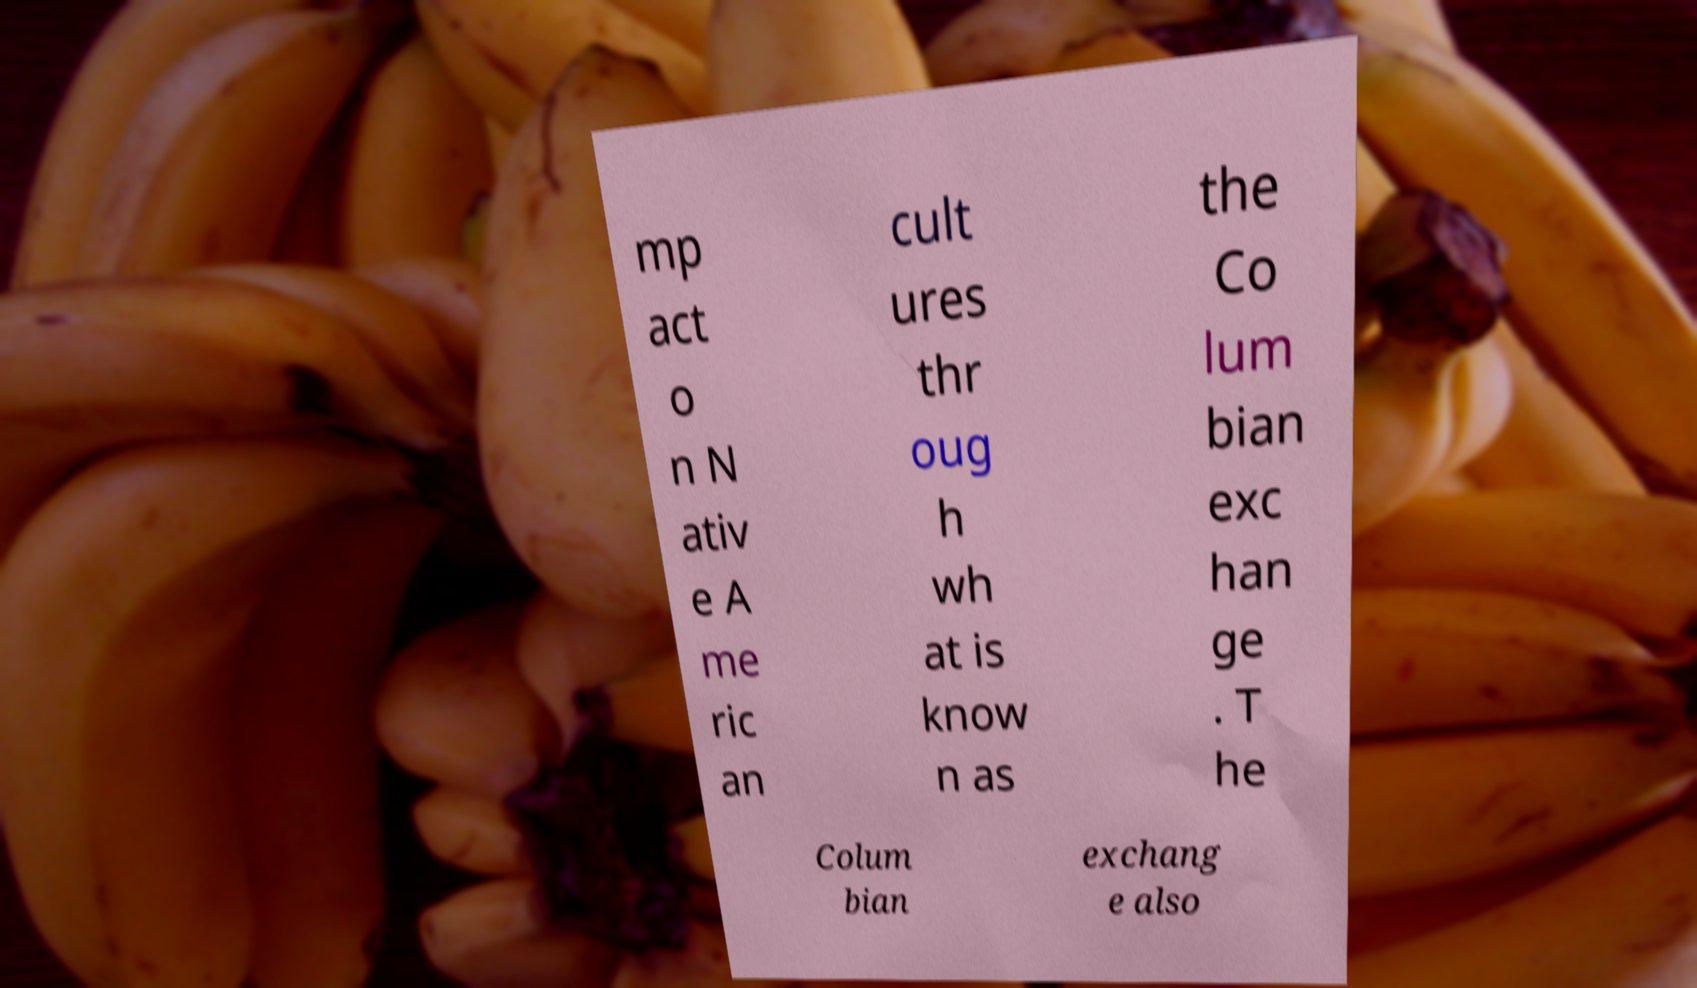Can you accurately transcribe the text from the provided image for me? mp act o n N ativ e A me ric an cult ures thr oug h wh at is know n as the Co lum bian exc han ge . T he Colum bian exchang e also 